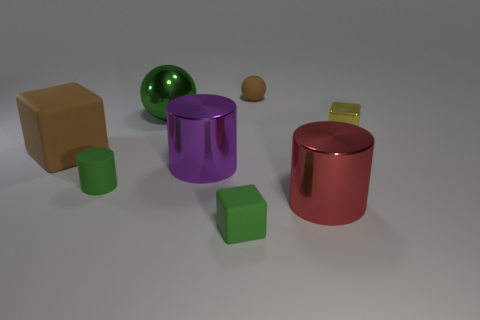What color is the matte cube in front of the brown object in front of the shiny sphere?
Make the answer very short. Green. Are there an equal number of small rubber cylinders in front of the tiny cylinder and small yellow shiny objects that are left of the large brown rubber object?
Make the answer very short. Yes. What number of cylinders are small gray objects or purple metal objects?
Provide a short and direct response. 1. There is a small green matte object that is left of the large green thing; what shape is it?
Give a very brief answer. Cylinder. The large object that is to the left of the tiny green matte thing that is to the left of the large purple metal cylinder is made of what material?
Your response must be concise. Rubber. Is the number of tiny yellow objects behind the tiny green block greater than the number of large blue metal cylinders?
Give a very brief answer. Yes. What number of other objects are the same color as the matte cylinder?
Provide a short and direct response. 2. The brown matte thing that is the same size as the green block is what shape?
Your answer should be compact. Sphere. There is a large shiny cylinder right of the brown matte thing that is behind the large green shiny sphere; what number of blocks are to the right of it?
Provide a short and direct response. 1. What number of metal objects are small brown balls or tiny green cubes?
Offer a very short reply. 0. 